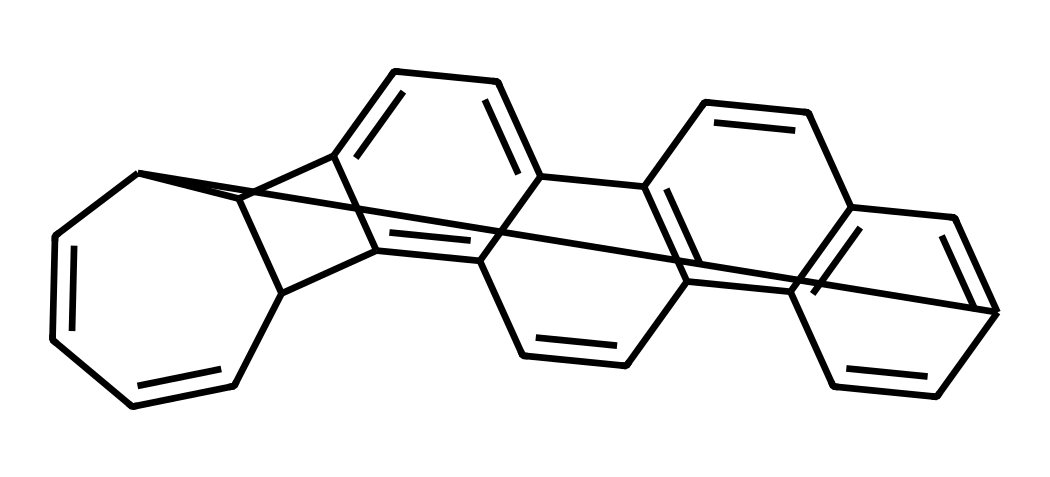What is the number of carbon atoms in corannulene? The SMILES representation shows a series of connected carbon atoms. By counting the 'C's in the SMILES or visually inspecting, we find that there are 20 carbon atoms in total.
Answer: 20 What type of geometry is observed in corannulene? Corannulene has a bowl shape, which can be inferred from the arrangement of its interconnected rings that create a curvature. This unique arrangement gives it a specific geometry categorized as "bowl-shaped".
Answer: bowl-shaped How many rings are present in the structure of corannulene? By analyzing the structure formed in the SMILES, we can identify that the molecule consists of five interconnected aromatic rings. The multiple aromatic cycles suggest a complex structure composed of rings.
Answer: 5 What is the major characteristic that distinguishes corannulene from typical fullerenes? Corannulene's distinct bowl shape, as opposed to the spherical or tubular shapes typical of fullerenes, sets it apart. This can be understood by considering its geometric structure and the connectivity of its carbon framework.
Answer: bowl shape How does the structure of corannulene relate to its potential applications? Due to its unique electronic properties stemming from its aromaticity and bowl shape, corannulene can be useful in applications involving organic electronics or nanotechnology. This reasoning highlights how the structural features contribute to its reactivity and practicality.
Answer: organic electronics 